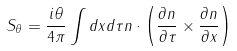<formula> <loc_0><loc_0><loc_500><loc_500>S _ { \theta } = \frac { i \theta } { 4 \pi } \int d x d \tau { n } \cdot \left ( \frac { \partial { n } } { \partial \tau } \times \frac { \partial { n } } { \partial x } \right )</formula> 